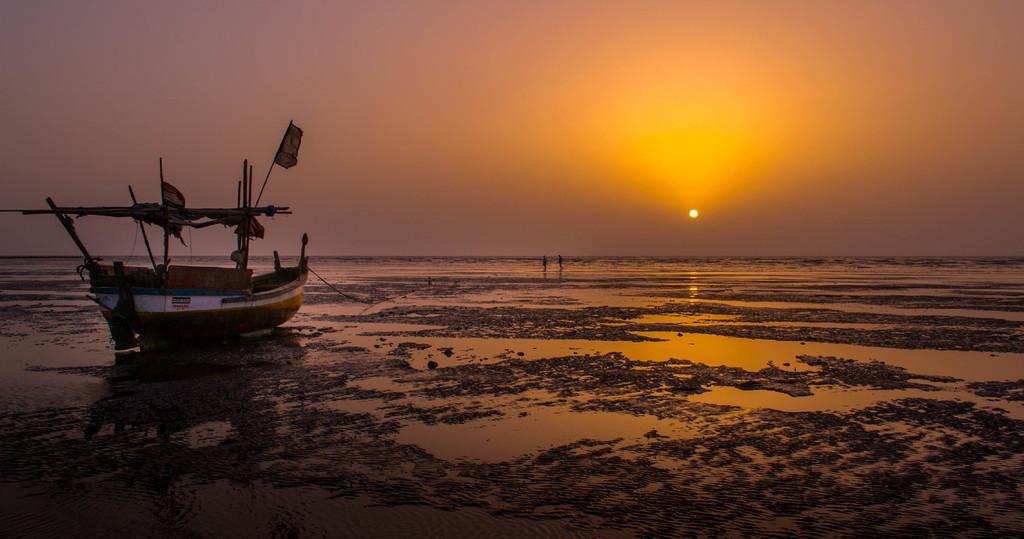Could you give a brief overview of what you see in this image? At the bottom of the image there is mud with water. And also there is a boat with poles. In the background there is water. At the top of the image there is a sky with sun. 